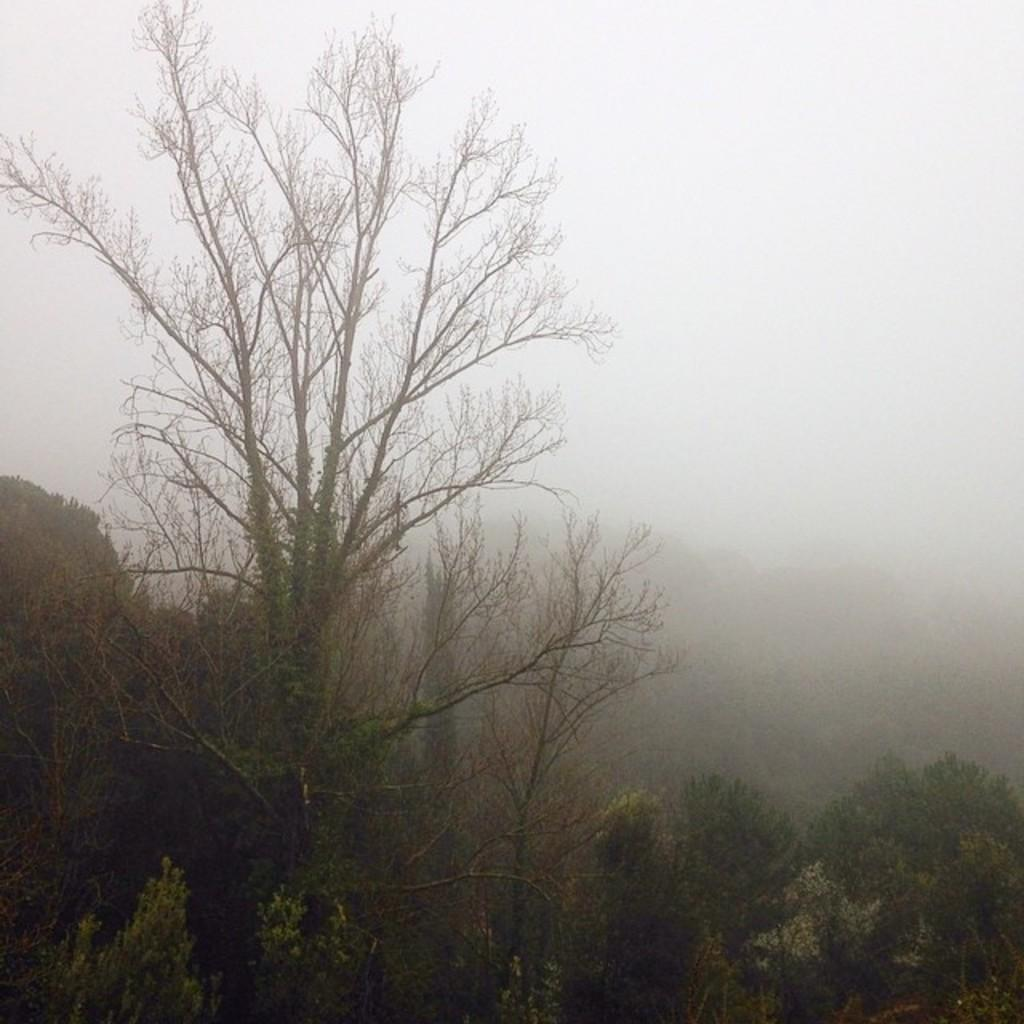What type of vegetation can be seen in the image? There are trees in the image. How would you describe the background of the image? The background of the image is blurry. Where is the basket located in the image? There is no basket present in the image. What type of friction can be observed between the trees in the image? The image does not show any friction between the trees. Can you see any ducks in the image? There are no ducks present in the image. 